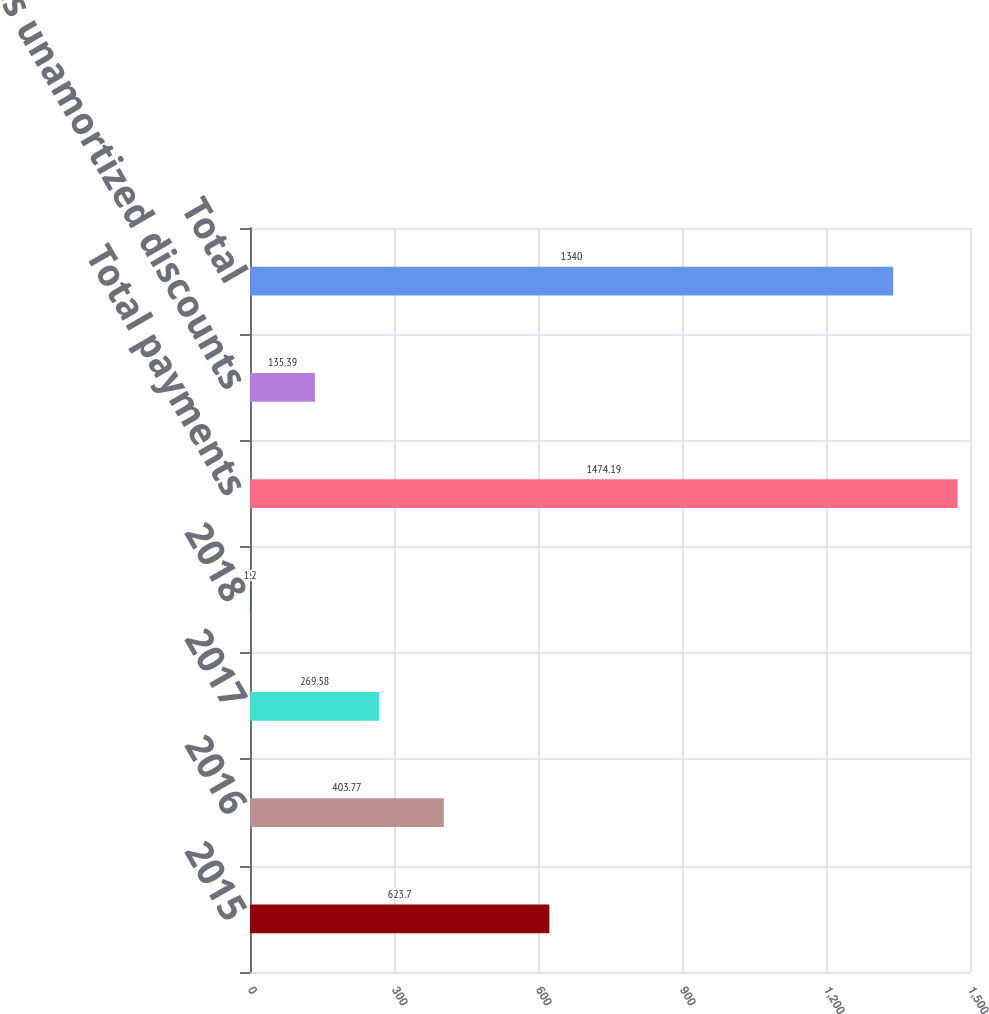Convert chart. <chart><loc_0><loc_0><loc_500><loc_500><bar_chart><fcel>2015<fcel>2016<fcel>2017<fcel>2018<fcel>Total payments<fcel>Less unamortized discounts<fcel>Total<nl><fcel>623.7<fcel>403.77<fcel>269.58<fcel>1.2<fcel>1474.19<fcel>135.39<fcel>1340<nl></chart> 